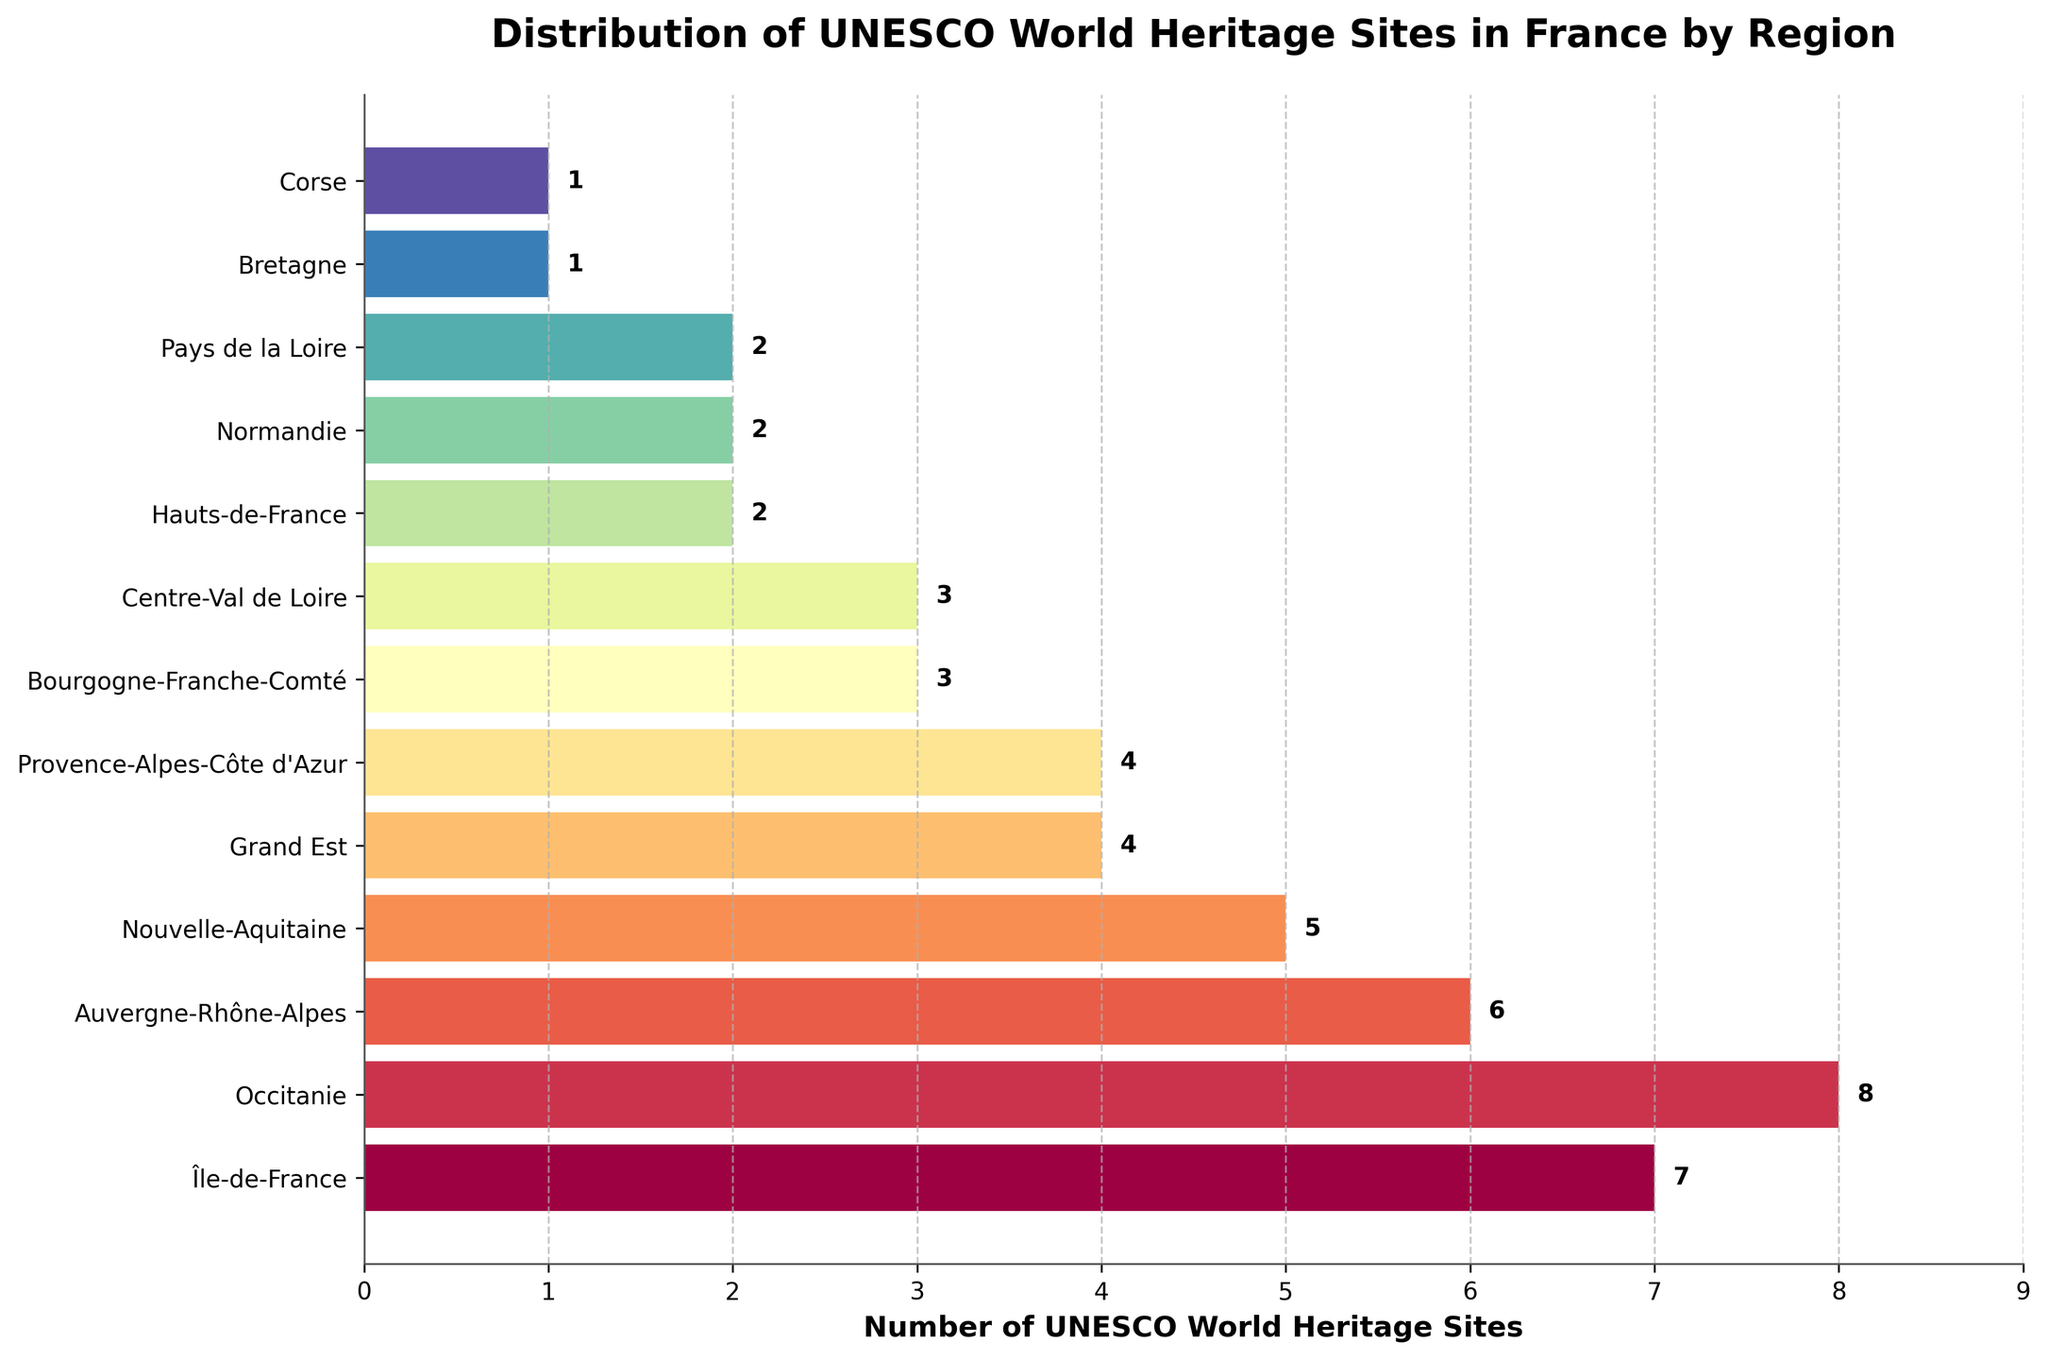Which region has the most UNESCO World Heritage Sites? The region with the highest bar represents the region with the most sites. Occitanie's bar is the highest, indicating it has the most UNESCO World Heritage Sites.
Answer: Occitanie Which regions have the same number of UNESCO World Heritage Sites? By comparing the length of the bars, we can see that Grand Est and Provence-Alpes-Côte d'Azur both have bars of the same length, indicating they have the same number of sites. They each have 4 sites. Similarly, Bourgogne-Franche-Comté and Centre-Val de Loire both have 3 sites, and Hauts-de-France, Normandie, and Pays de la Loire each have 2 sites. Bretagne and Corse both have 1 site.
Answer: Grand Est & Provence-Alpes-Côte d'Azur; Bourgogne-Franche-Comté & Centre-Val de Loire; Hauts-de-France, Normandie & Pays de la Loire; Bretagne & Corse How many more UNESCO World Heritage Sites does Île-de-France have compared to Corse? Île-de-France has 7 sites and Corse has 1 site. The difference can be calculated by subtracting the number of sites in Corse from Île-de-France: 7 - 1 = 6.
Answer: 6 What is the total number of UNESCO World Heritage Sites across all regions? Sum the number of sites in each region: 7 + 8 + 6 + 5 + 4 + 4 + 3 + 3 + 2 + 2 + 2 + 1 + 1 = 48.
Answer: 48 Which region has the third highest number of UNESCO World Heritage Sites? Occitanie has the most (8), followed by Île-de-France (7). The next highest is Auvergne-Rhône-Alpes with 6 sites.
Answer: Auvergne-Rhône-Alpes Is the number of UNESCO World Heritage Sites in Nouvelle-Aquitaine greater than in Provence-Alpes-Côte d'Azur? Compare the lengths of their respective bars. Nouvelle-Aquitaine has 5 sites and Provence-Alpes-Côte d'Azur has 4 sites. 5 is greater than 4.
Answer: Yes What is the average number of UNESCO World Heritage Sites per region? Total number of sites (48) divided by the number of regions (13): 48 / 13 ≈ 3.69.
Answer: 3.69 If Bourgogne-Franche-Comté, Centre-Val de Loire, and Nouvelle-Aquitaine are combined into one larger region, what will be the total number of UNESCO World Heritage Sites in this new region? Sum the number of sites for these regions: Bourgogne-Franche-Comté (3), Centre-Val de Loire (3), and Nouvelle-Aquitaine (5): 3 + 3 + 5 = 11.
Answer: 11 Which region has the shortest bar? The regions with the shortest bars have 1 site each. Both Bretagne and Corse have the shortest bars.
Answer: Bretagne & Corse 